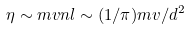<formula> <loc_0><loc_0><loc_500><loc_500>\eta \sim m v n l \sim ( 1 / \pi ) m v / d ^ { 2 }</formula> 